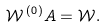<formula> <loc_0><loc_0><loc_500><loc_500>\mathcal { W } ^ { \, ( 0 ) } A = \mathcal { W } .</formula> 